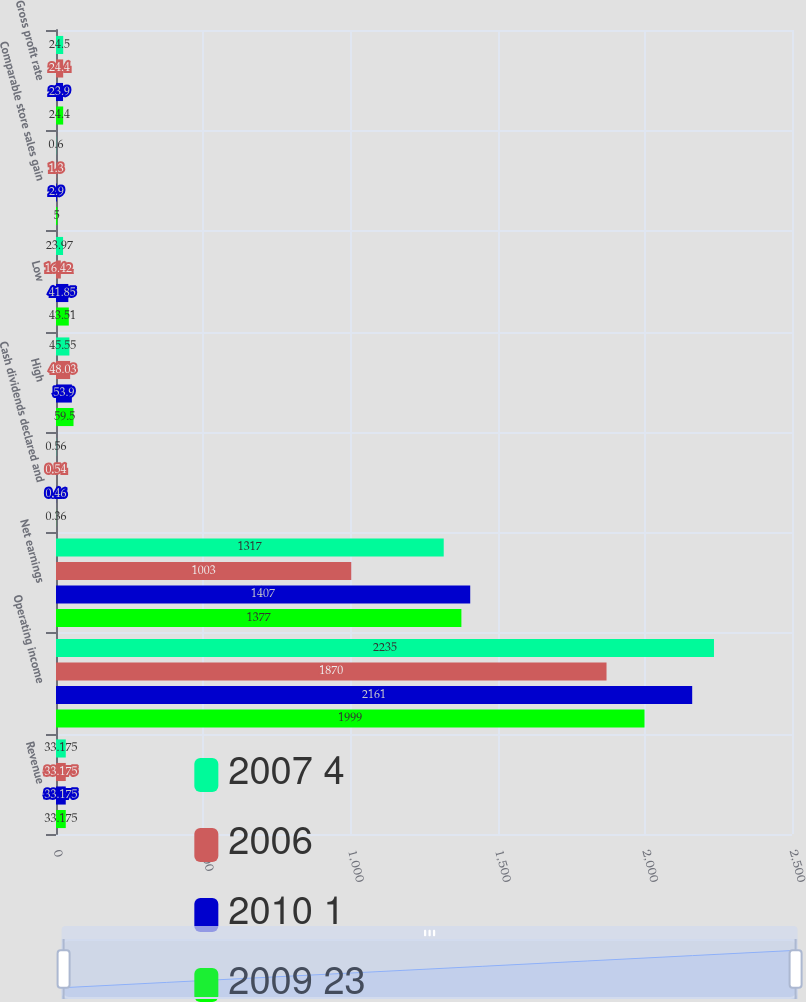<chart> <loc_0><loc_0><loc_500><loc_500><stacked_bar_chart><ecel><fcel>Revenue<fcel>Operating income<fcel>Net earnings<fcel>Cash dividends declared and<fcel>High<fcel>Low<fcel>Comparable store sales gain<fcel>Gross profit rate<nl><fcel>2007 4<fcel>33.175<fcel>2235<fcel>1317<fcel>0.56<fcel>45.55<fcel>23.97<fcel>0.6<fcel>24.5<nl><fcel>2006<fcel>33.175<fcel>1870<fcel>1003<fcel>0.54<fcel>48.03<fcel>16.42<fcel>1.3<fcel>24.4<nl><fcel>2010 1<fcel>33.175<fcel>2161<fcel>1407<fcel>0.46<fcel>53.9<fcel>41.85<fcel>2.9<fcel>23.9<nl><fcel>2009 23<fcel>33.175<fcel>1999<fcel>1377<fcel>0.36<fcel>59.5<fcel>43.51<fcel>5<fcel>24.4<nl></chart> 